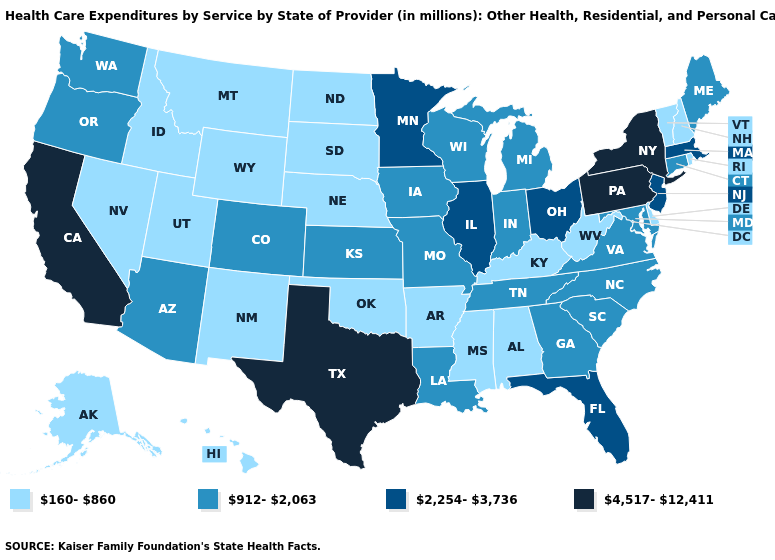Among the states that border Utah , which have the lowest value?
Keep it brief. Idaho, Nevada, New Mexico, Wyoming. Does the map have missing data?
Concise answer only. No. Which states have the lowest value in the USA?
Keep it brief. Alabama, Alaska, Arkansas, Delaware, Hawaii, Idaho, Kentucky, Mississippi, Montana, Nebraska, Nevada, New Hampshire, New Mexico, North Dakota, Oklahoma, Rhode Island, South Dakota, Utah, Vermont, West Virginia, Wyoming. What is the value of West Virginia?
Short answer required. 160-860. What is the highest value in states that border Massachusetts?
Quick response, please. 4,517-12,411. Among the states that border Ohio , which have the highest value?
Be succinct. Pennsylvania. What is the lowest value in the South?
Be succinct. 160-860. Name the states that have a value in the range 4,517-12,411?
Answer briefly. California, New York, Pennsylvania, Texas. What is the value of Massachusetts?
Keep it brief. 2,254-3,736. Name the states that have a value in the range 160-860?
Be succinct. Alabama, Alaska, Arkansas, Delaware, Hawaii, Idaho, Kentucky, Mississippi, Montana, Nebraska, Nevada, New Hampshire, New Mexico, North Dakota, Oklahoma, Rhode Island, South Dakota, Utah, Vermont, West Virginia, Wyoming. Name the states that have a value in the range 160-860?
Quick response, please. Alabama, Alaska, Arkansas, Delaware, Hawaii, Idaho, Kentucky, Mississippi, Montana, Nebraska, Nevada, New Hampshire, New Mexico, North Dakota, Oklahoma, Rhode Island, South Dakota, Utah, Vermont, West Virginia, Wyoming. Name the states that have a value in the range 2,254-3,736?
Answer briefly. Florida, Illinois, Massachusetts, Minnesota, New Jersey, Ohio. Does Mississippi have the lowest value in the USA?
Keep it brief. Yes. Name the states that have a value in the range 2,254-3,736?
Keep it brief. Florida, Illinois, Massachusetts, Minnesota, New Jersey, Ohio. 